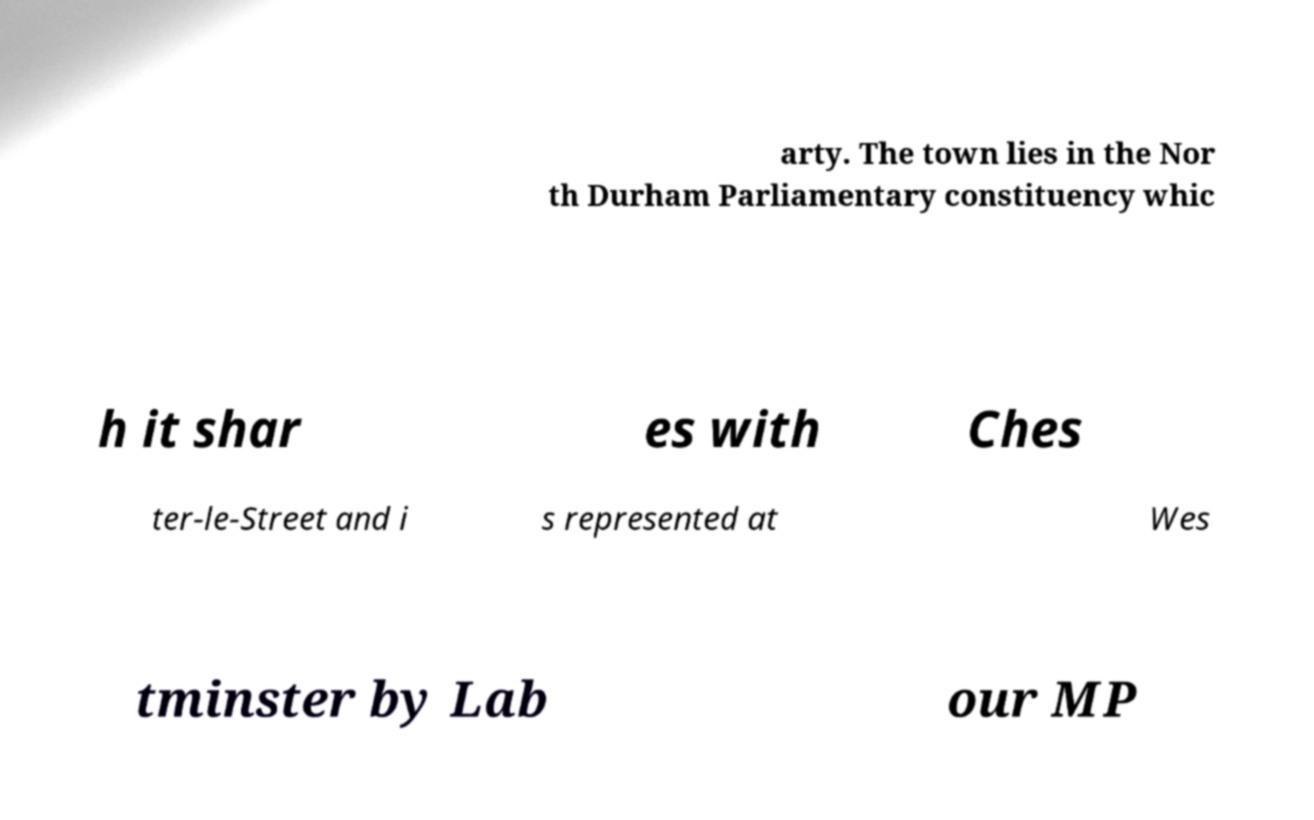Could you assist in decoding the text presented in this image and type it out clearly? arty. The town lies in the Nor th Durham Parliamentary constituency whic h it shar es with Ches ter-le-Street and i s represented at Wes tminster by Lab our MP 